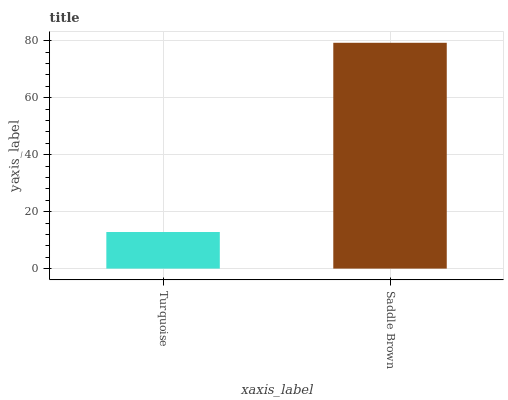Is Saddle Brown the minimum?
Answer yes or no. No. Is Saddle Brown greater than Turquoise?
Answer yes or no. Yes. Is Turquoise less than Saddle Brown?
Answer yes or no. Yes. Is Turquoise greater than Saddle Brown?
Answer yes or no. No. Is Saddle Brown less than Turquoise?
Answer yes or no. No. Is Saddle Brown the high median?
Answer yes or no. Yes. Is Turquoise the low median?
Answer yes or no. Yes. Is Turquoise the high median?
Answer yes or no. No. Is Saddle Brown the low median?
Answer yes or no. No. 